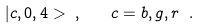<formula> <loc_0><loc_0><loc_500><loc_500>| c , 0 , 4 > \ , \quad c = b , g , r \ .</formula> 